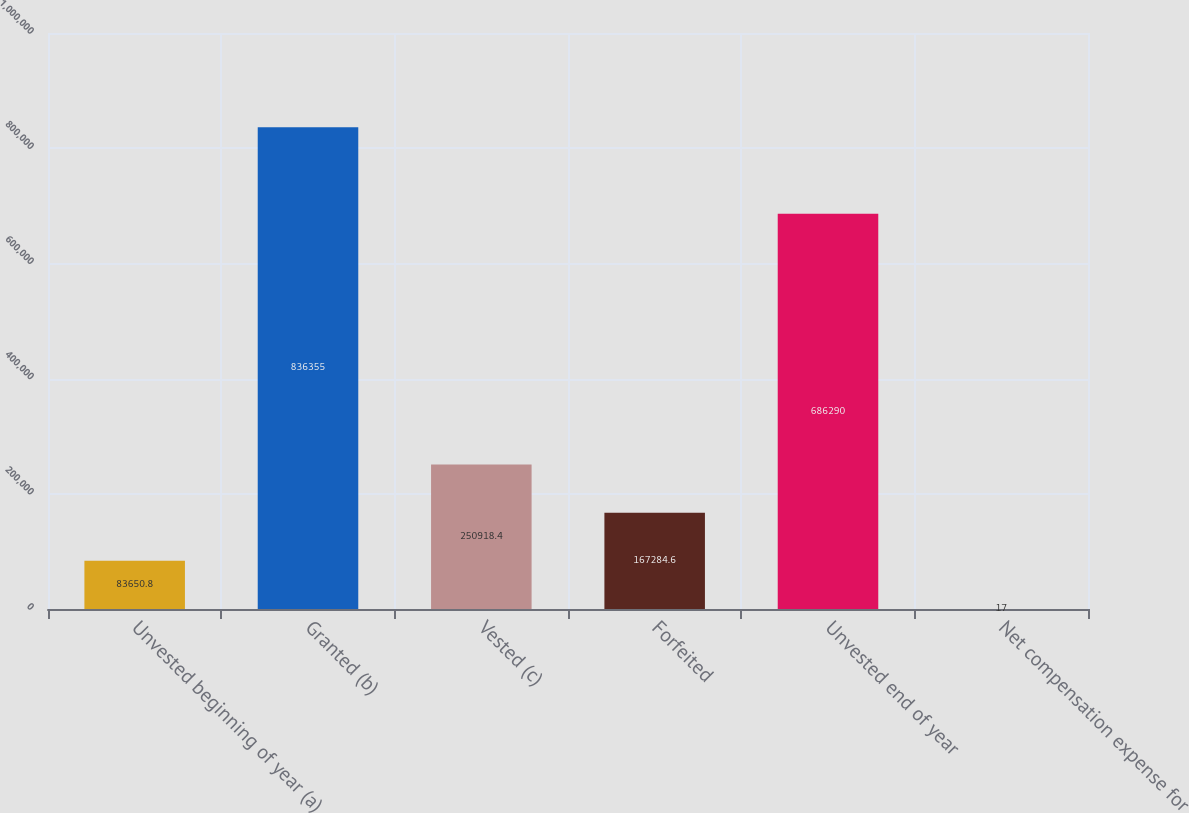<chart> <loc_0><loc_0><loc_500><loc_500><bar_chart><fcel>Unvested beginning of year (a)<fcel>Granted (b)<fcel>Vested (c)<fcel>Forfeited<fcel>Unvested end of year<fcel>Net compensation expense for<nl><fcel>83650.8<fcel>836355<fcel>250918<fcel>167285<fcel>686290<fcel>17<nl></chart> 